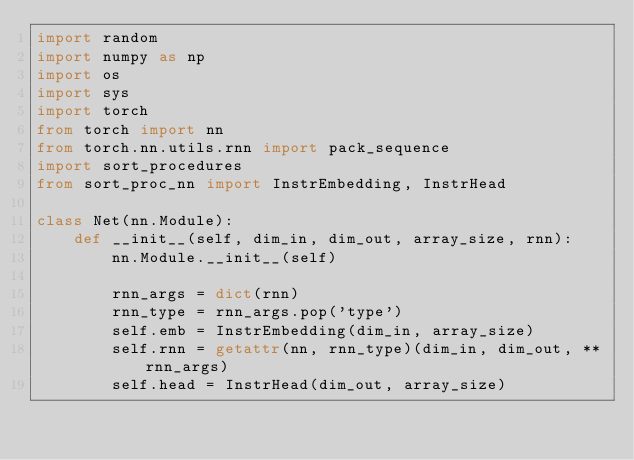<code> <loc_0><loc_0><loc_500><loc_500><_Python_>import random
import numpy as np
import os
import sys
import torch
from torch import nn
from torch.nn.utils.rnn import pack_sequence
import sort_procedures
from sort_proc_nn import InstrEmbedding, InstrHead

class Net(nn.Module):
    def __init__(self, dim_in, dim_out, array_size, rnn):
        nn.Module.__init__(self)

        rnn_args = dict(rnn)
        rnn_type = rnn_args.pop('type')
        self.emb = InstrEmbedding(dim_in, array_size)
        self.rnn = getattr(nn, rnn_type)(dim_in, dim_out, **rnn_args)
        self.head = InstrHead(dim_out, array_size)
</code> 